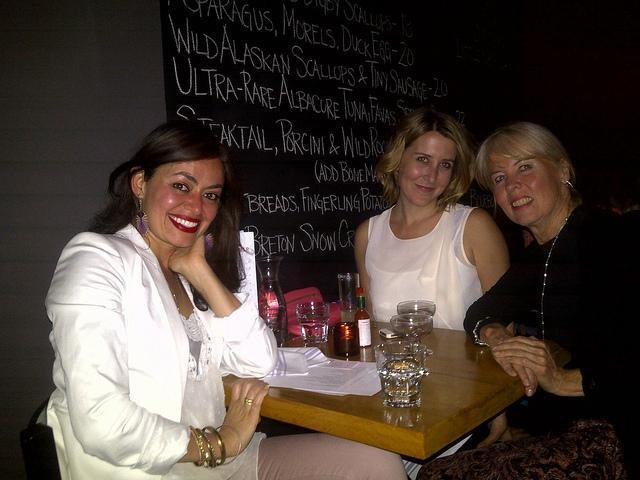How many women are there?
Give a very brief answer. 3. How many men are here?
Give a very brief answer. 0. How many people are in the picture?
Give a very brief answer. 3. 